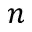<formula> <loc_0><loc_0><loc_500><loc_500>n</formula> 